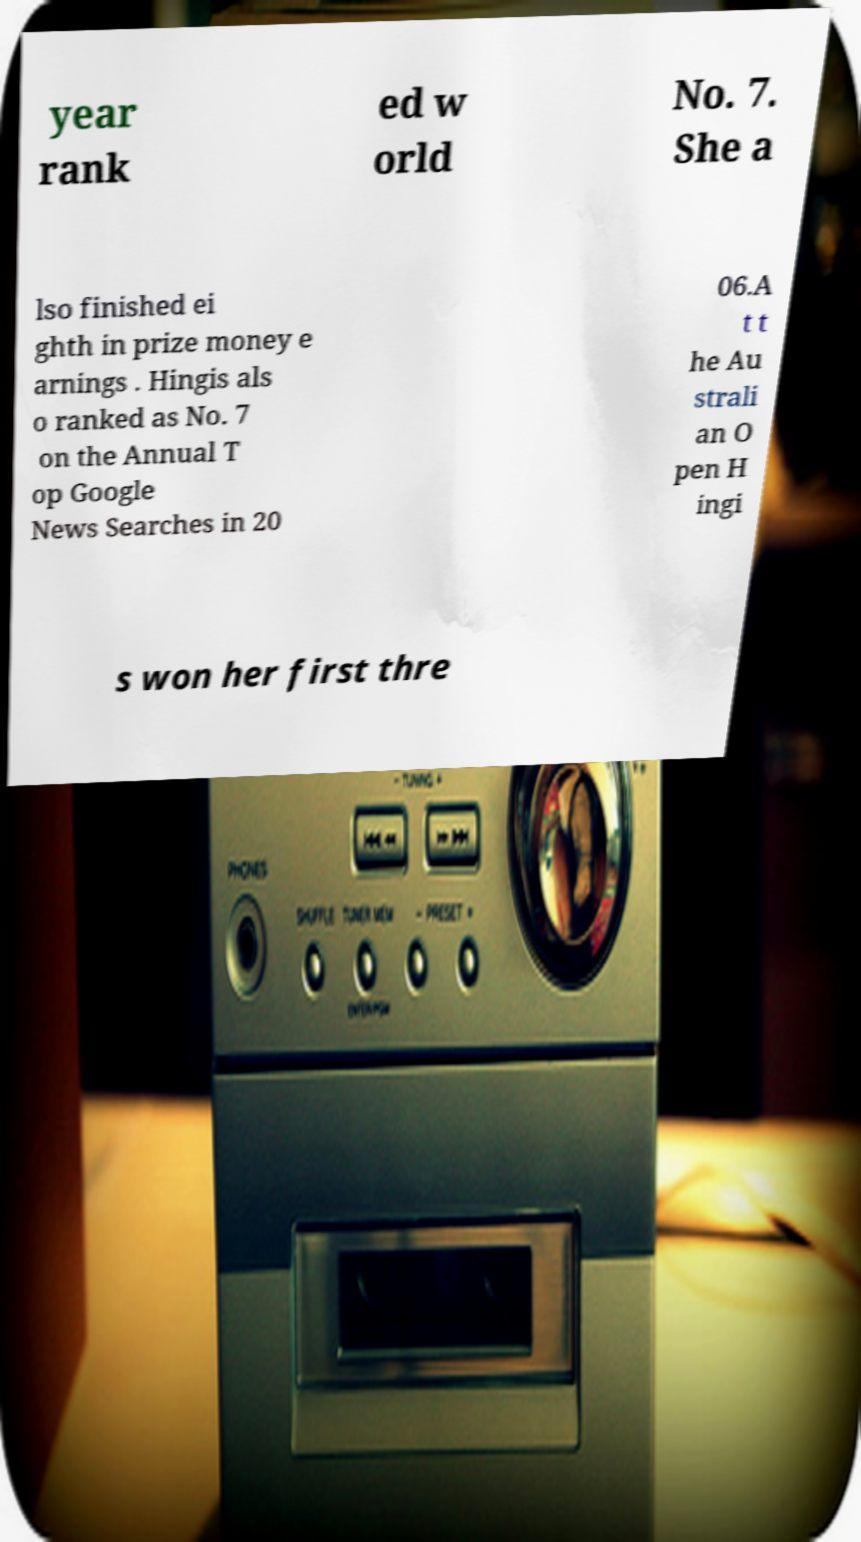For documentation purposes, I need the text within this image transcribed. Could you provide that? year rank ed w orld No. 7. She a lso finished ei ghth in prize money e arnings . Hingis als o ranked as No. 7 on the Annual T op Google News Searches in 20 06.A t t he Au strali an O pen H ingi s won her first thre 